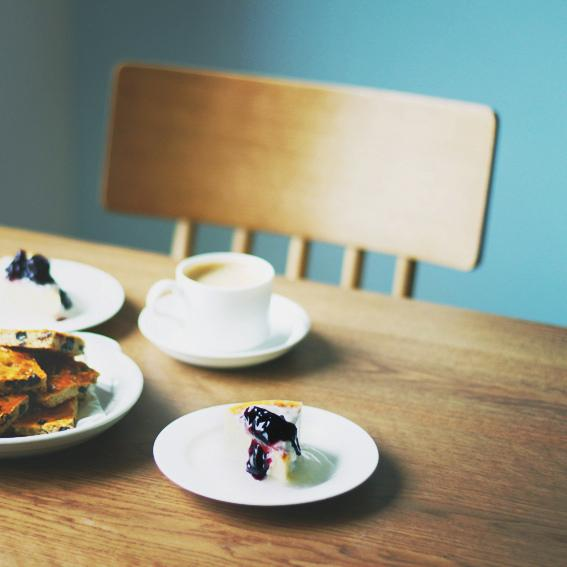What meal is being served? dessert 